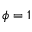Convert formula to latex. <formula><loc_0><loc_0><loc_500><loc_500>\phi = 1</formula> 